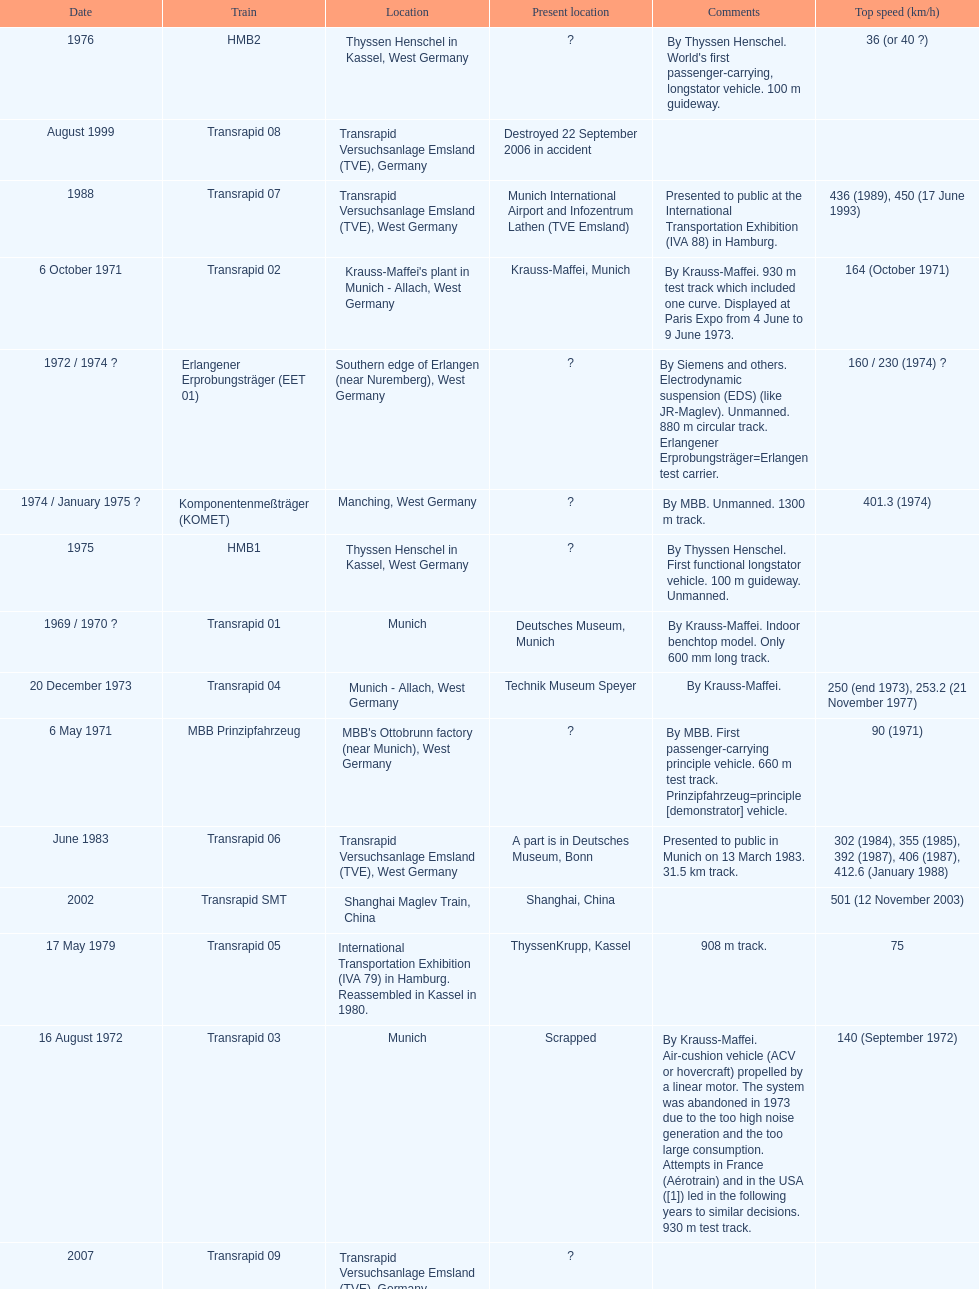What train was developed after the erlangener erprobungstrager? Transrapid 04. 